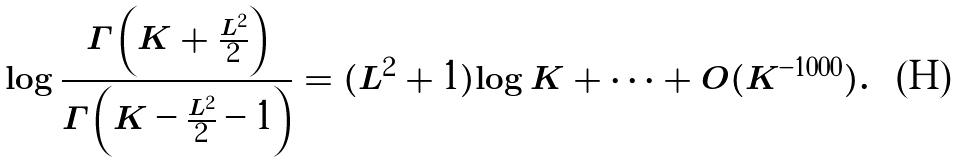<formula> <loc_0><loc_0><loc_500><loc_500>\log \frac { \Gamma \left ( K + \frac { L ^ { 2 } } { 2 } \right ) } { \Gamma \left ( K - \frac { L ^ { 2 } } { 2 } - 1 \right ) } = ( L ^ { 2 } + 1 ) \log K + \cdots + O ( K ^ { - 1 0 0 0 } ) .</formula> 